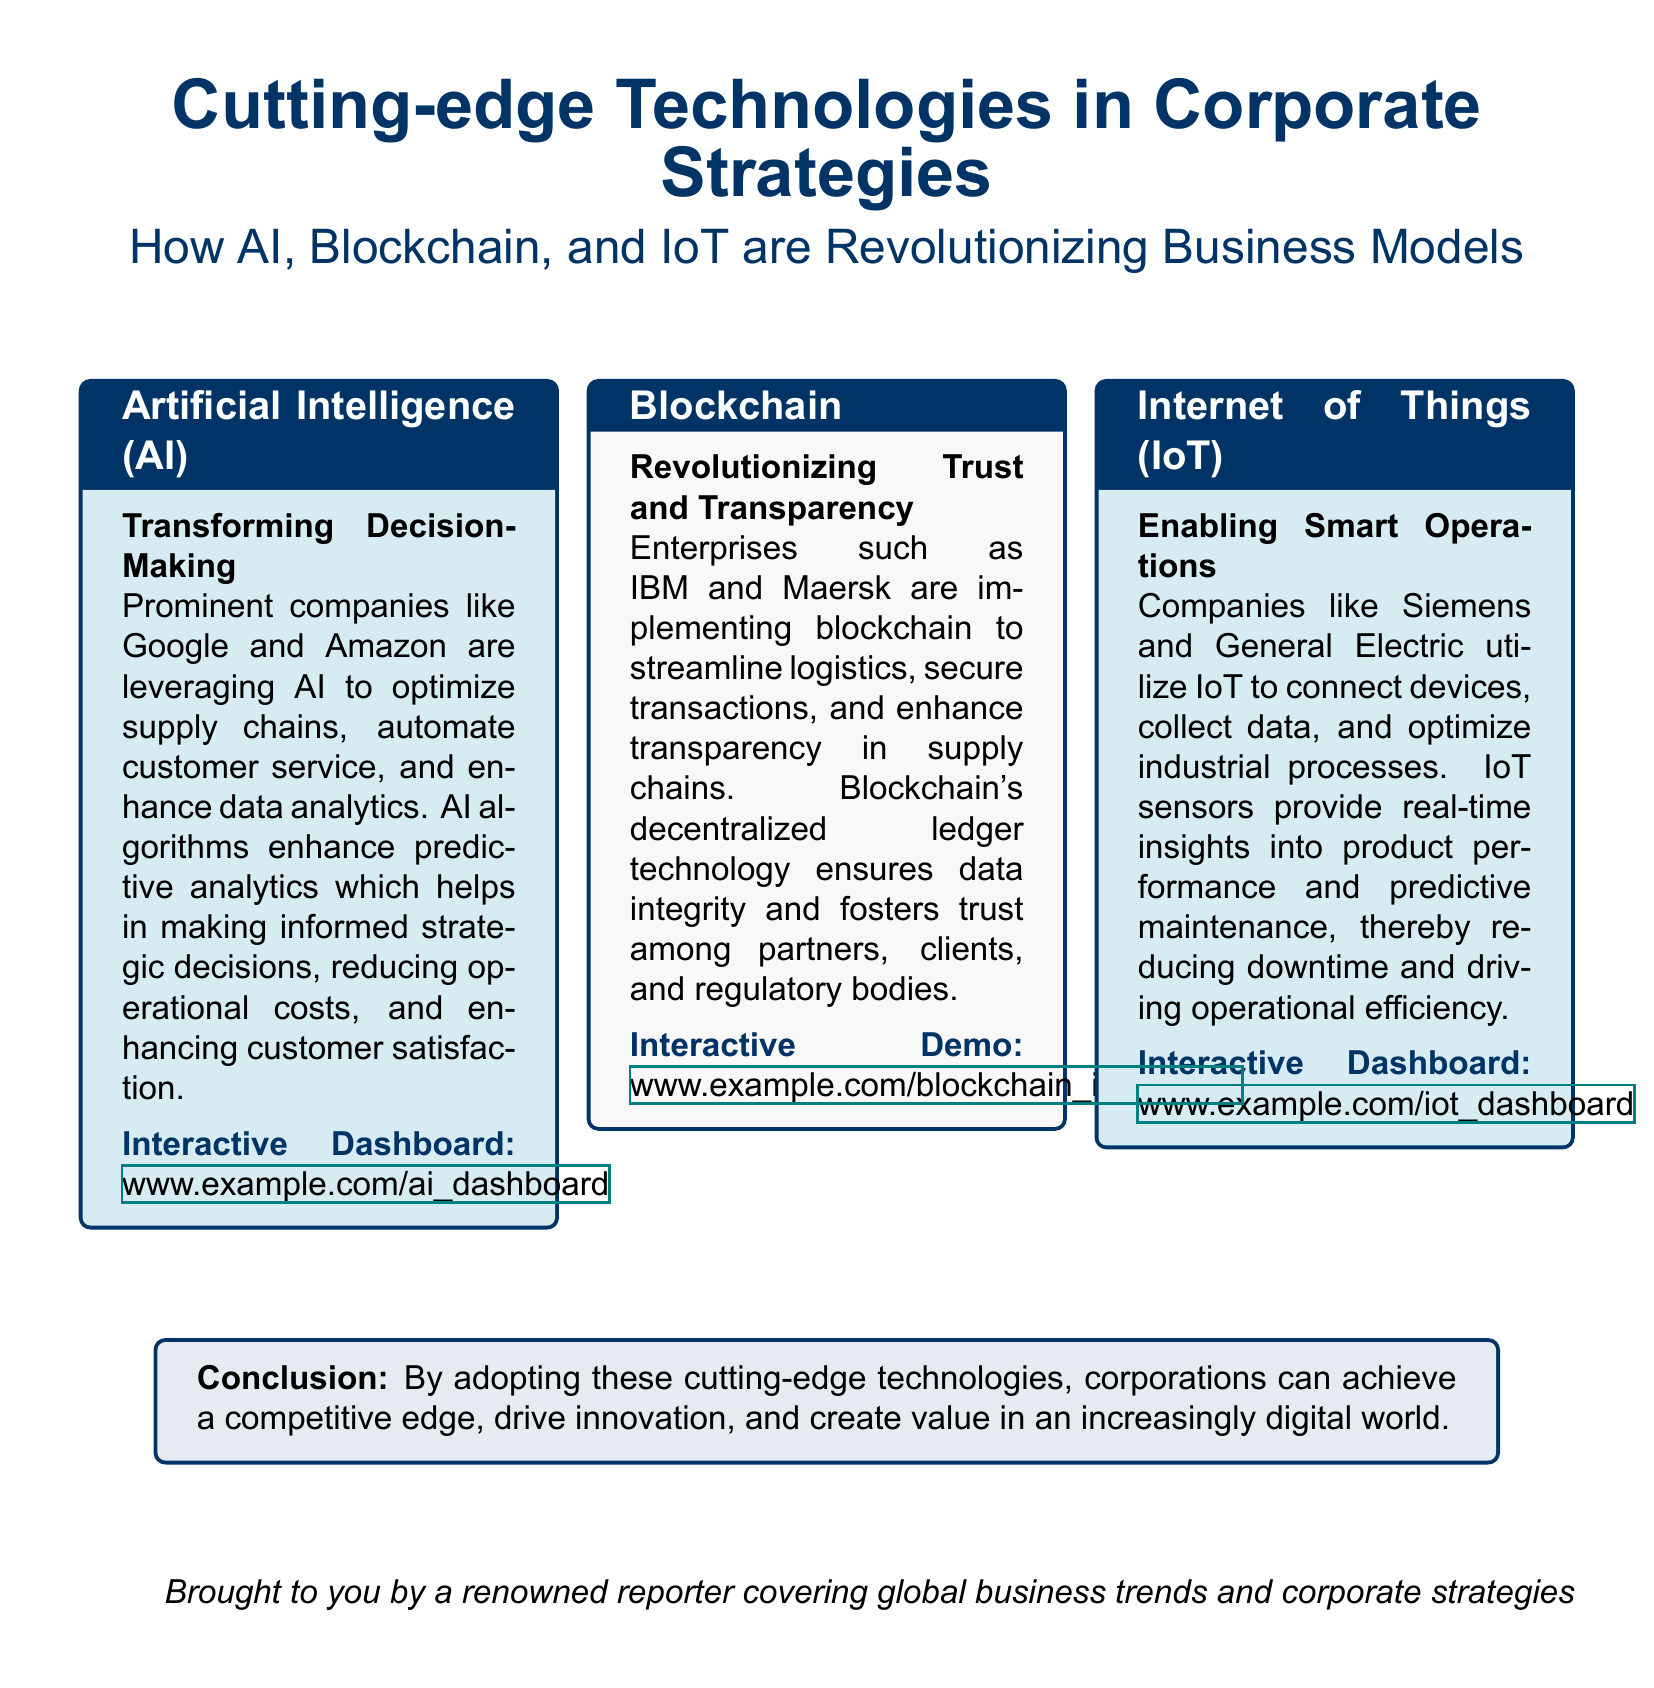What technologies are showcased in the document? The document mentions AI, Blockchain, and IoT as the technologies reshaping corporate strategies.
Answer: AI, Blockchain, IoT Which company is associated with AI according to the document? The companies Google and Amazon are specifically mentioned in relation to AI usage.
Answer: Google, Amazon What is the purpose of Blockchain as mentioned in the document? The document states that Blockchain is used to enhance trust and transparency in supply chains.
Answer: Trust and transparency What type of interactive element is included for AI? The document provides a link to an interactive dashboard for AI.
Answer: Interactive Dashboard Which industries are mentioned to utilize IoT? Siemens and General Electric are the companies highlighted for their use of IoT.
Answer: Siemens, General Electric What conclusion does the document present about cutting-edge technologies? The conclusion outlines that adopting these technologies can give corporations a competitive edge and drive innovation.
Answer: Competitive edge How does AI enhance decision-making according to the document? AI enhances decision-making through predictive analytics, operational cost reduction, and improved customer satisfaction.
Answer: Predictive analytics What interactive feature is offered for Blockchain? The document includes a link to an interactive demo for Blockchain.
Answer: Interactive Demo 